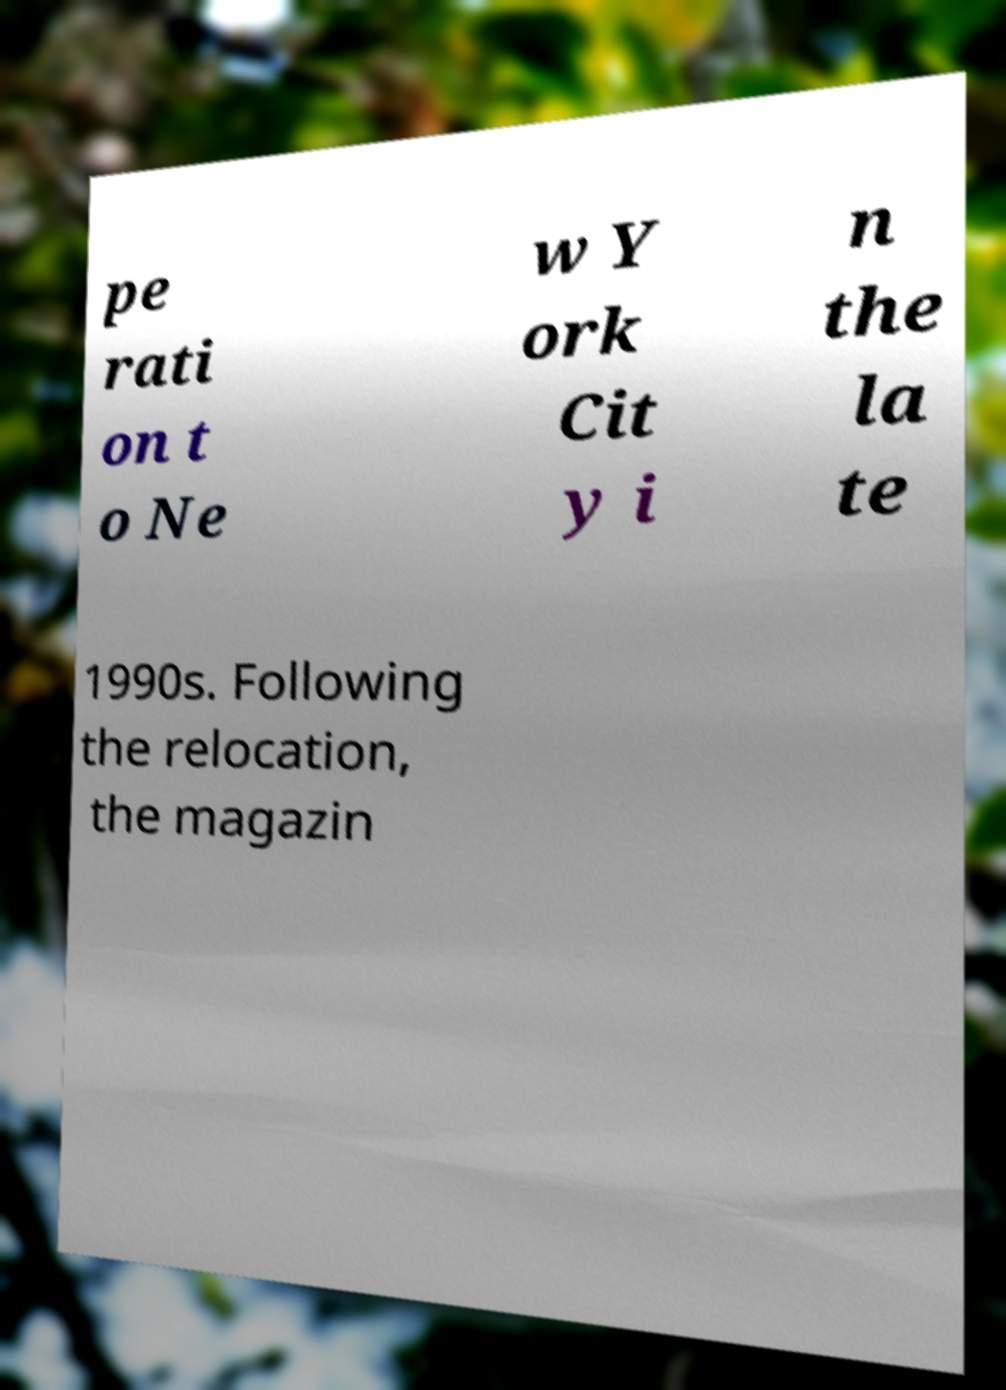Could you extract and type out the text from this image? pe rati on t o Ne w Y ork Cit y i n the la te 1990s. Following the relocation, the magazin 